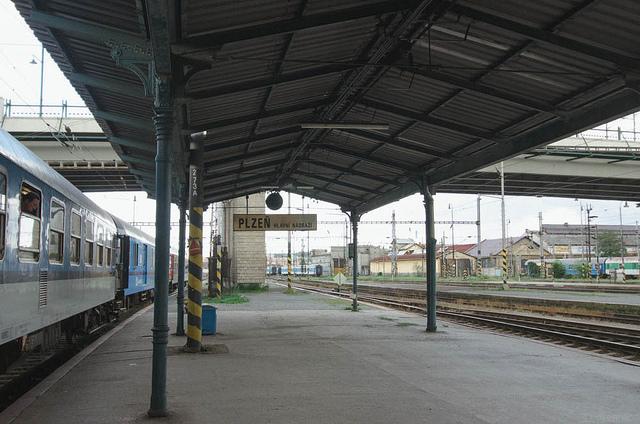Is there a train in the depot?
Quick response, please. Yes. What pattern is on the pole?
Short answer required. Stripe. Is now a good time to run across the platform?
Short answer required. Yes. Is there a crowd of people waiting to get on the train?
Short answer required. No. Yes they are?
Give a very brief answer. No. What is the train on the left doing?
Write a very short answer. Waiting. 